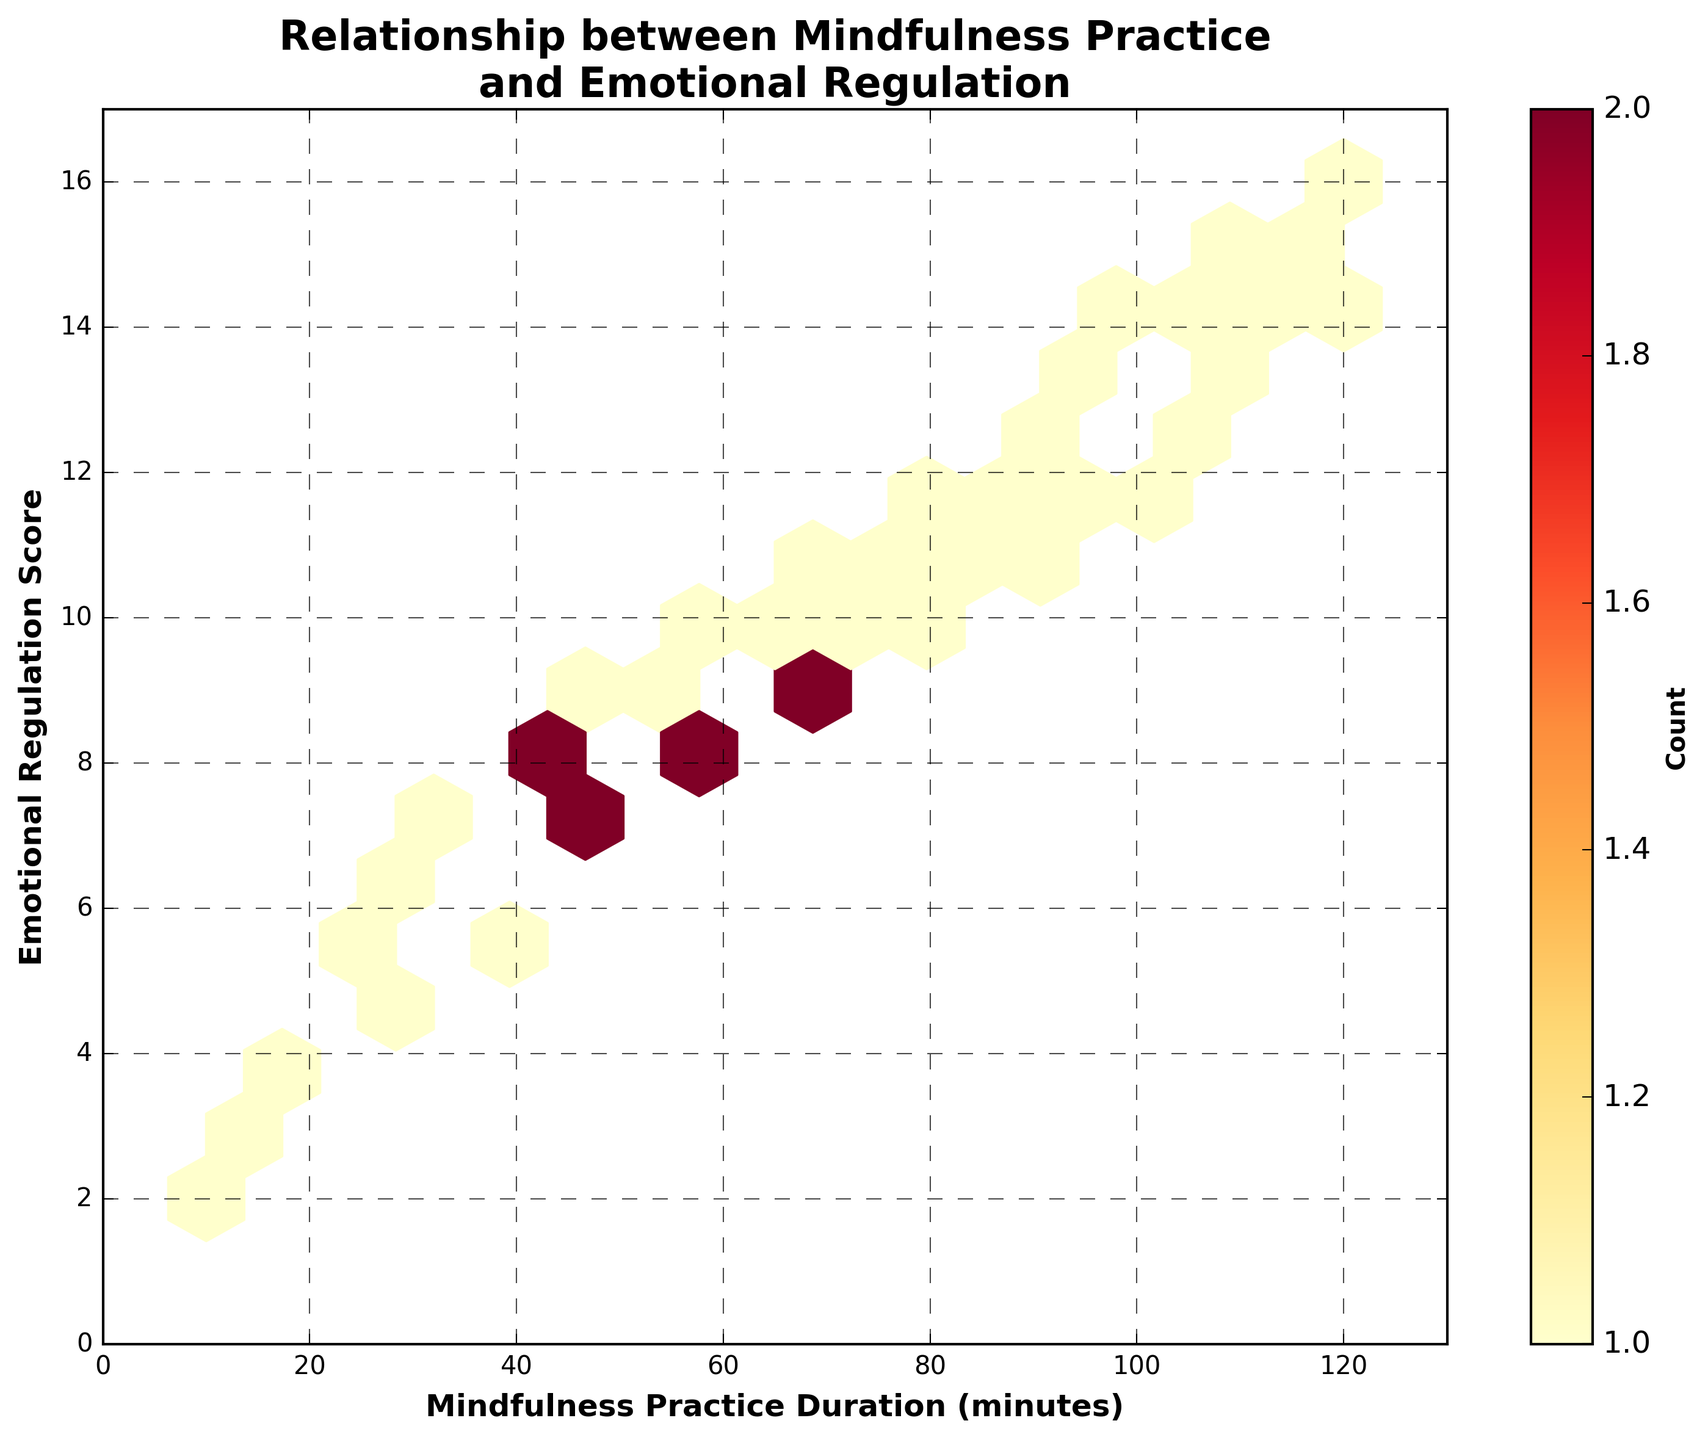What is the title of the hexbin plot? The title of the hexbin plot is displayed at the top and provides a summary of what the plot represents. It reads "Relationship between Mindfulness Practice and Emotional Regulation".
Answer: Relationship between Mindfulness Practice and Emotional Regulation What is the range of the x-axis representing mindfulness practice duration? The x-axis represents the mindfulness practice duration in minutes and ranges from 0 to slightly above the maximum data point, which is 120 minutes. The limit on the x-axis is set from 0 to 130 minutes.
Answer: 0 to 130 minutes How many data points are aggregated in the most densely populated hexbin? The color bar labeled 'Count' on the right helps determine the density of data points in each hex bin. The darkest hexagon represents the highest count, matching the darkest color on the color bar which has a count value of 3.
Answer: 3 Based on the plot, does a longer mindfulness practice duration generally relate to higher emotional regulation scores? The scatter of data points tends to move from the lower-left to the upper-right of the plot, indicating that as mindfulness practice duration increases, emotional regulation scores also tend to increase.
Answer: Yes What is the range of the y-axis representing emotional regulation scores? The y-axis, representing emotional regulation scores, ranges from 0 to slightly above the maximum data point, which is 16. The limit on the y-axis is set from 0 to 17.
Answer: 0 to 17 Compare the emotional regulation scores for mindfulness practice durations of 30 minutes and 60 minutes. The hexbin plot shows that for 30 minutes of practice, the emotional regulation scores are around 6, whereas, for 60 minutes of practice, the scores are around 8.
Answer: 30 min: ~6, 60 min: ~8 What does the color of the hexagons represent? The color of the hexagons signifies the count of overlapped data points within that hexagon. This is indicated by the color bar on the right side, where different shadings represent different counts.
Answer: Count of data points If we focus on the hexagon representing 40 minutes in practice duration, what is the range of emotional regulation scores? The hexagon at 40 minutes practice duration encapsulates emotional regulation scores ranging from approximately 6 to 8.
Answer: 6 to 8 Considering the hexbin plot, how extensively does the overlap of data points affect our interpretation? The overlap is represented by the intensity of colors in the hexagons. Darker hexagons indicate multiple data points in that region, suggesting that conclusions drawn from more populated hexagons are statistically more significant.
Answer: Significantly 